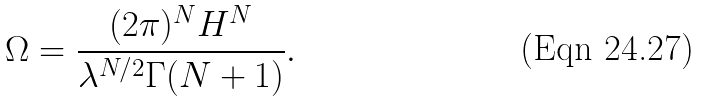Convert formula to latex. <formula><loc_0><loc_0><loc_500><loc_500>\Omega = \frac { ( 2 \pi ) ^ { N } H ^ { N } } { \lambda ^ { N / 2 } \Gamma ( N + 1 ) } .</formula> 